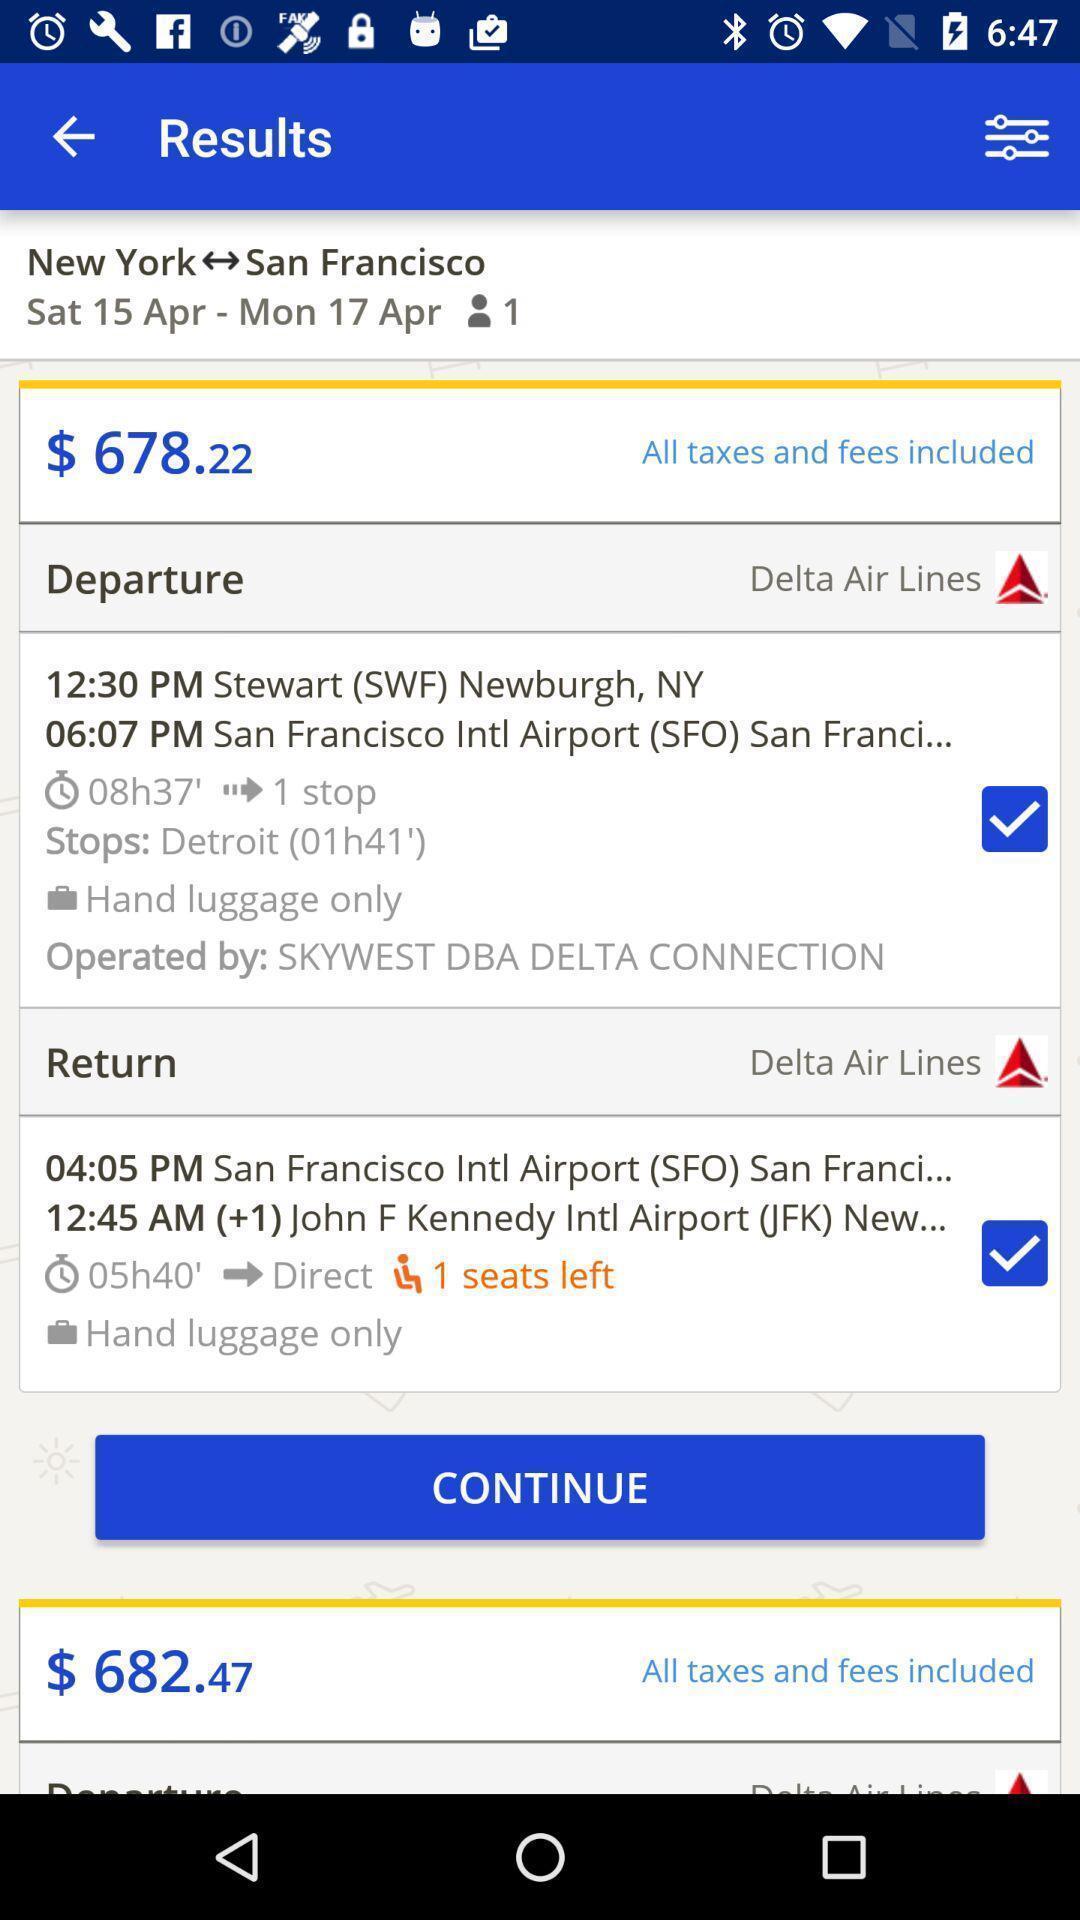What details can you identify in this image? Page displaying the financial information of the app. 